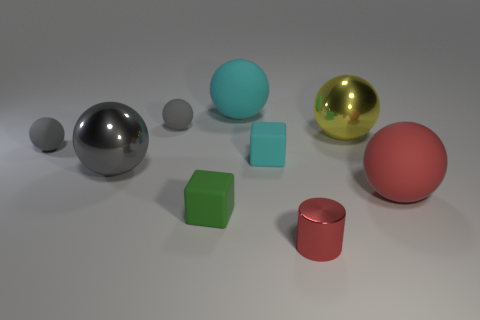What is the color of the tiny metallic object?
Your answer should be compact. Red. What is the size of the ball that is on the left side of the large red rubber thing and right of the tiny cylinder?
Your response must be concise. Large. What number of objects are small objects that are in front of the red rubber thing or gray matte balls?
Provide a short and direct response. 4. The small cyan thing that is the same material as the green thing is what shape?
Ensure brevity in your answer.  Cube. What is the shape of the large red thing?
Offer a terse response. Sphere. The matte object that is on the right side of the cyan ball and to the left of the big yellow object is what color?
Your answer should be compact. Cyan. What shape is the cyan rubber object that is the same size as the green thing?
Your answer should be very brief. Cube. Are there any other tiny shiny things of the same shape as the small metallic thing?
Offer a terse response. No. Is the green thing made of the same material as the tiny cube behind the red rubber sphere?
Keep it short and to the point. Yes. What color is the large shiny object that is left of the small matte object that is in front of the matte object that is right of the small shiny object?
Provide a succinct answer. Gray. 